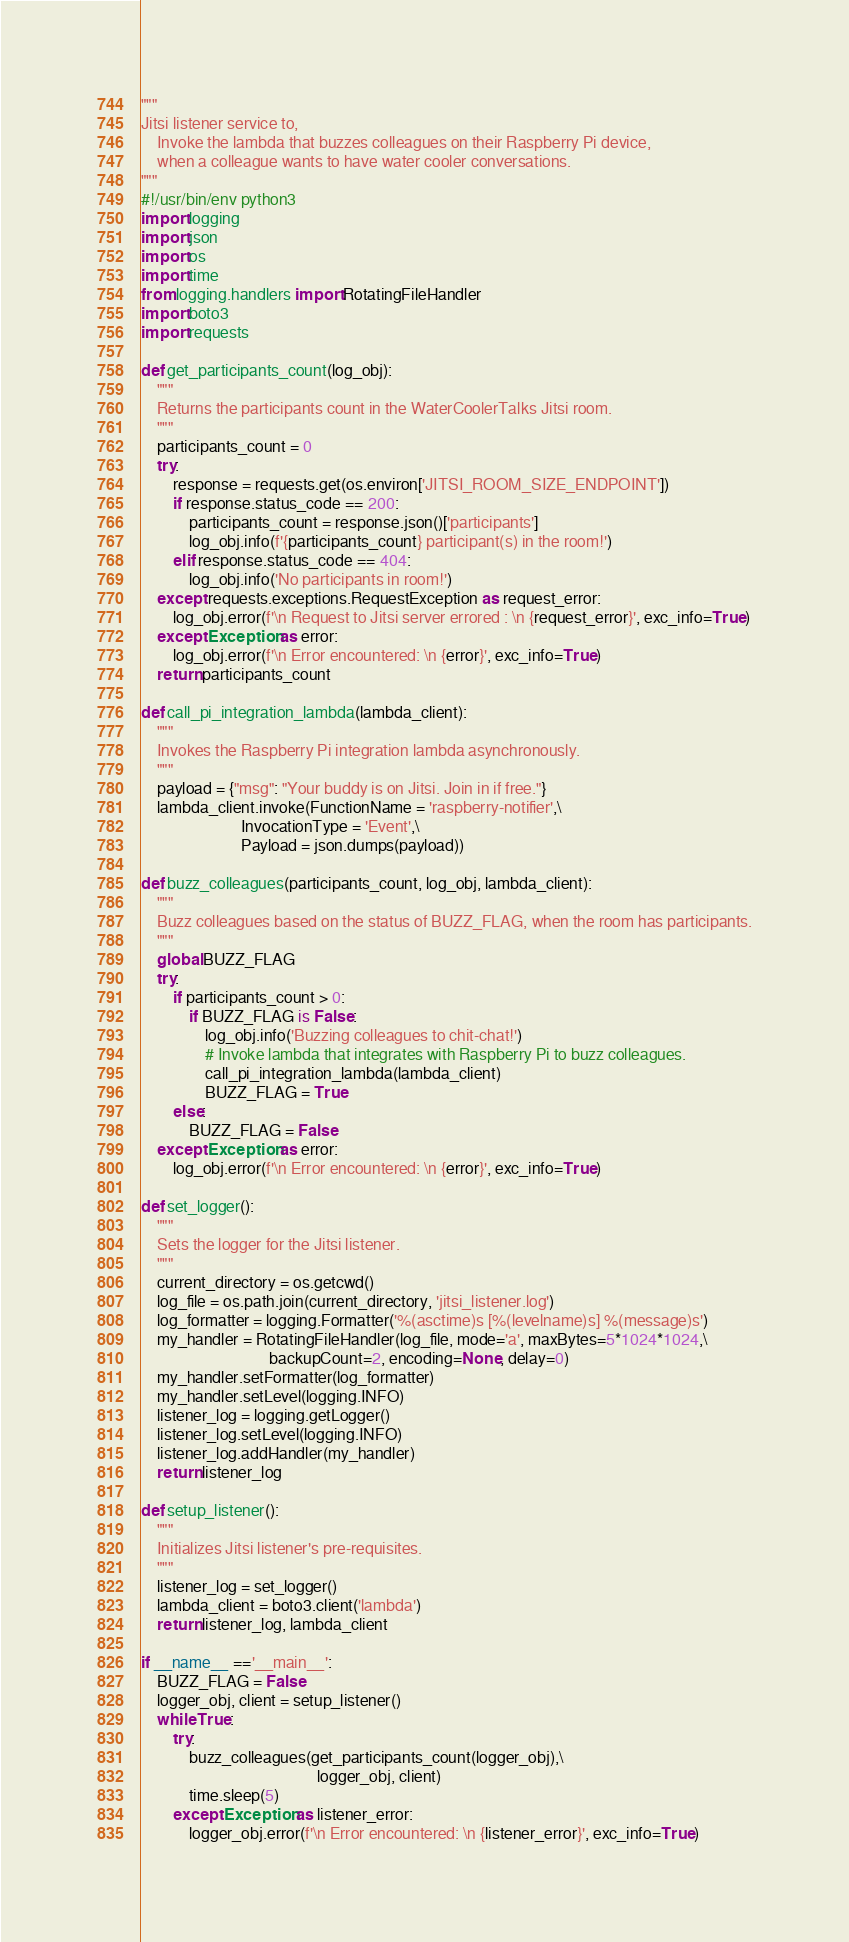Convert code to text. <code><loc_0><loc_0><loc_500><loc_500><_Python_>"""
Jitsi listener service to,
    Invoke the lambda that buzzes colleagues on their Raspberry Pi device,
    when a colleague wants to have water cooler conversations.
"""
#!/usr/bin/env python3
import logging
import json
import os
import time
from logging.handlers import RotatingFileHandler
import boto3
import requests

def get_participants_count(log_obj):
    """
    Returns the participants count in the WaterCoolerTalks Jitsi room.
    """
    participants_count = 0
    try:
        response = requests.get(os.environ['JITSI_ROOM_SIZE_ENDPOINT'])
        if response.status_code == 200:
            participants_count = response.json()['participants']
            log_obj.info(f'{participants_count} participant(s) in the room!')
        elif response.status_code == 404:
            log_obj.info('No participants in room!')
    except requests.exceptions.RequestException as request_error:
        log_obj.error(f'\n Request to Jitsi server errored : \n {request_error}', exc_info=True)
    except Exception as error:
        log_obj.error(f'\n Error encountered: \n {error}', exc_info=True)
    return participants_count

def call_pi_integration_lambda(lambda_client):
    """
    Invokes the Raspberry Pi integration lambda asynchronously.
    """
    payload = {"msg": "Your buddy is on Jitsi. Join in if free."}
    lambda_client.invoke(FunctionName = 'raspberry-notifier',\
                         InvocationType = 'Event',\
                         Payload = json.dumps(payload))

def buzz_colleagues(participants_count, log_obj, lambda_client):
    """
    Buzz colleagues based on the status of BUZZ_FLAG, when the room has participants.
    """
    global BUZZ_FLAG
    try:
        if participants_count > 0:
            if BUZZ_FLAG is False:
                log_obj.info('Buzzing colleagues to chit-chat!')
                # Invoke lambda that integrates with Raspberry Pi to buzz colleagues.
                call_pi_integration_lambda(lambda_client)
                BUZZ_FLAG = True
        else:
            BUZZ_FLAG = False
    except Exception as error:
        log_obj.error(f'\n Error encountered: \n {error}', exc_info=True)

def set_logger():
    """
    Sets the logger for the Jitsi listener.
    """
    current_directory = os.getcwd()
    log_file = os.path.join(current_directory, 'jitsi_listener.log')
    log_formatter = logging.Formatter('%(asctime)s [%(levelname)s] %(message)s')
    my_handler = RotatingFileHandler(log_file, mode='a', maxBytes=5*1024*1024,\
                                backupCount=2, encoding=None, delay=0)
    my_handler.setFormatter(log_formatter)
    my_handler.setLevel(logging.INFO)
    listener_log = logging.getLogger()
    listener_log.setLevel(logging.INFO)
    listener_log.addHandler(my_handler)
    return listener_log

def setup_listener():
    """
    Initializes Jitsi listener's pre-requisites.
    """
    listener_log = set_logger()
    lambda_client = boto3.client('lambda')
    return listener_log, lambda_client

if __name__ =='__main__':
    BUZZ_FLAG = False
    logger_obj, client = setup_listener()
    while True:
        try:
            buzz_colleagues(get_participants_count(logger_obj),\
                                            logger_obj, client)
            time.sleep(5)
        except Exception as listener_error:
            logger_obj.error(f'\n Error encountered: \n {listener_error}', exc_info=True)
</code> 